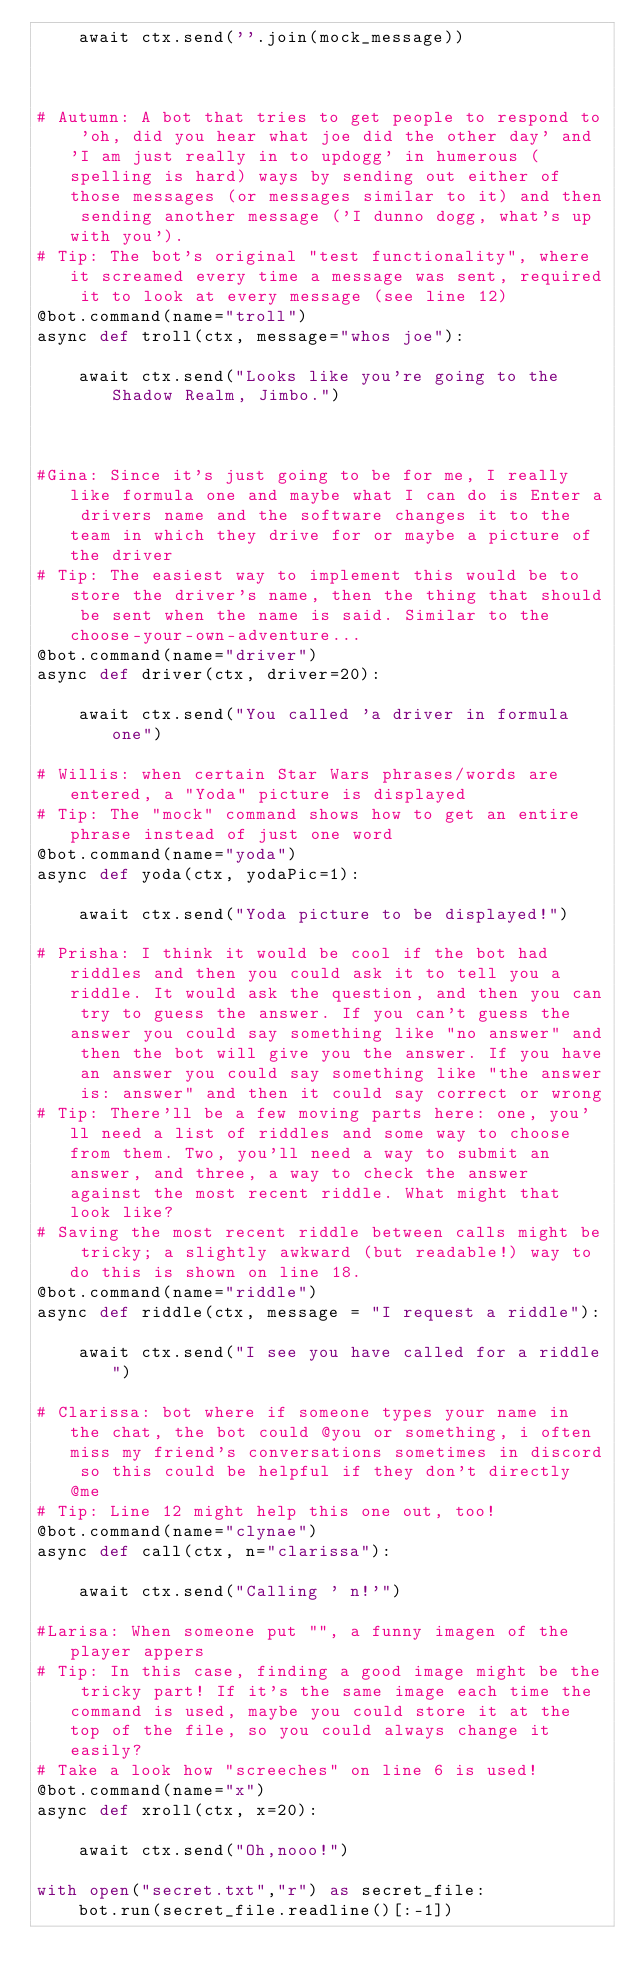<code> <loc_0><loc_0><loc_500><loc_500><_Python_>    await ctx.send(''.join(mock_message))



# Autumn: A bot that tries to get people to respond to 'oh, did you hear what joe did the other day' and 'I am just really in to updogg' in humerous (spelling is hard) ways by sending out either of those messages (or messages similar to it) and then sending another message ('I dunno dogg, what's up with you').
# Tip: The bot's original "test functionality", where it screamed every time a message was sent, required it to look at every message (see line 12)
@bot.command(name="troll")
async def troll(ctx, message="whos joe"):

    await ctx.send("Looks like you're going to the Shadow Realm, Jimbo.")



#Gina: Since it's just going to be for me, I really like formula one and maybe what I can do is Enter a drivers name and the software changes it to the team in which they drive for or maybe a picture of the driver
# Tip: The easiest way to implement this would be to store the driver's name, then the thing that should be sent when the name is said. Similar to the choose-your-own-adventure...
@bot.command(name="driver")
async def driver(ctx, driver=20):

    await ctx.send("You called 'a driver in formula one")

# Willis: when certain Star Wars phrases/words are entered, a "Yoda" picture is displayed
# Tip: The "mock" command shows how to get an entire phrase instead of just one word
@bot.command(name="yoda")
async def yoda(ctx, yodaPic=1):

    await ctx.send("Yoda picture to be displayed!")

# Prisha: I think it would be cool if the bot had riddles and then you could ask it to tell you a riddle. It would ask the question, and then you can try to guess the answer. If you can't guess the answer you could say something like "no answer" and then the bot will give you the answer. If you have an answer you could say something like "the answer is: answer" and then it could say correct or wrong
# Tip: There'll be a few moving parts here: one, you'll need a list of riddles and some way to choose from them. Two, you'll need a way to submit an answer, and three, a way to check the answer against the most recent riddle. What might that look like?
# Saving the most recent riddle between calls might be tricky; a slightly awkward (but readable!) way to do this is shown on line 18.
@bot.command(name="riddle")
async def riddle(ctx, message = "I request a riddle"):

    await ctx.send("I see you have called for a riddle")

# Clarissa: bot where if someone types your name in the chat, the bot could @you or something, i often miss my friend's conversations sometimes in discord so this could be helpful if they don't directly @me
# Tip: Line 12 might help this one out, too!
@bot.command(name="clynae")
async def call(ctx, n="clarissa"):

    await ctx.send("Calling ' n!'")

#Larisa: When someone put "", a funny imagen of the player appers
# Tip: In this case, finding a good image might be the tricky part! If it's the same image each time the command is used, maybe you could store it at the top of the file, so you could always change it easily?
# Take a look how "screeches" on line 6 is used!
@bot.command(name="x")
async def xroll(ctx, x=20):

    await ctx.send("Oh,nooo!")

with open("secret.txt","r") as secret_file:
    bot.run(secret_file.readline()[:-1])
</code> 